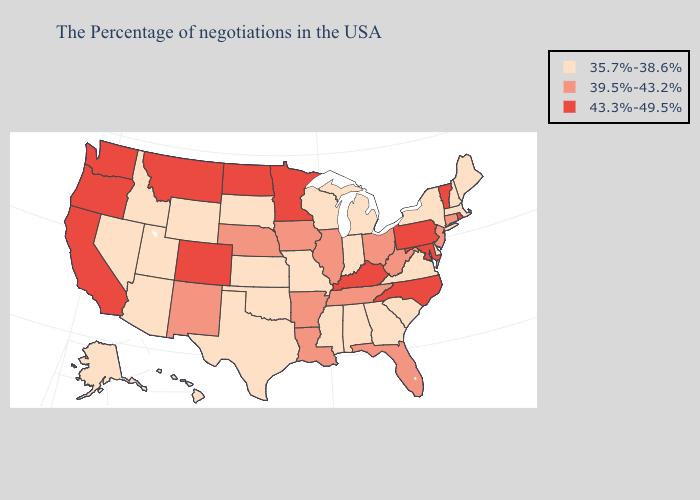Name the states that have a value in the range 35.7%-38.6%?
Quick response, please. Maine, Massachusetts, New Hampshire, New York, Delaware, Virginia, South Carolina, Georgia, Michigan, Indiana, Alabama, Wisconsin, Mississippi, Missouri, Kansas, Oklahoma, Texas, South Dakota, Wyoming, Utah, Arizona, Idaho, Nevada, Alaska, Hawaii. Name the states that have a value in the range 35.7%-38.6%?
Short answer required. Maine, Massachusetts, New Hampshire, New York, Delaware, Virginia, South Carolina, Georgia, Michigan, Indiana, Alabama, Wisconsin, Mississippi, Missouri, Kansas, Oklahoma, Texas, South Dakota, Wyoming, Utah, Arizona, Idaho, Nevada, Alaska, Hawaii. Among the states that border Nevada , does Utah have the highest value?
Answer briefly. No. Name the states that have a value in the range 43.3%-49.5%?
Answer briefly. Rhode Island, Vermont, Maryland, Pennsylvania, North Carolina, Kentucky, Minnesota, North Dakota, Colorado, Montana, California, Washington, Oregon. Among the states that border Utah , does New Mexico have the highest value?
Give a very brief answer. No. Does Vermont have the same value as Montana?
Concise answer only. Yes. What is the lowest value in the USA?
Short answer required. 35.7%-38.6%. Does New York have the lowest value in the Northeast?
Be succinct. Yes. What is the value of Connecticut?
Answer briefly. 39.5%-43.2%. Name the states that have a value in the range 43.3%-49.5%?
Concise answer only. Rhode Island, Vermont, Maryland, Pennsylvania, North Carolina, Kentucky, Minnesota, North Dakota, Colorado, Montana, California, Washington, Oregon. Name the states that have a value in the range 43.3%-49.5%?
Be succinct. Rhode Island, Vermont, Maryland, Pennsylvania, North Carolina, Kentucky, Minnesota, North Dakota, Colorado, Montana, California, Washington, Oregon. What is the highest value in states that border Missouri?
Keep it brief. 43.3%-49.5%. What is the highest value in the USA?
Short answer required. 43.3%-49.5%. Does Washington have a higher value than Indiana?
Give a very brief answer. Yes. What is the value of New Jersey?
Keep it brief. 39.5%-43.2%. 